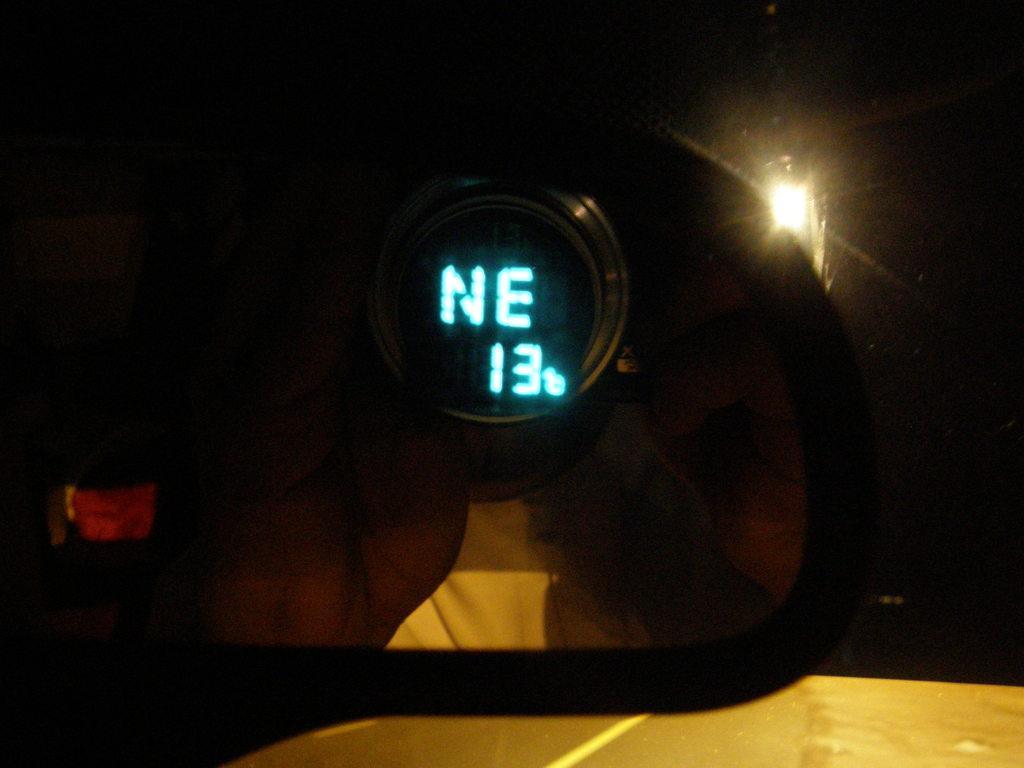Can you describe this image briefly? Here in this picture we can see a mirror of a vehicle and in that we can see some digital text present and behind that we can see a lamp post present on the ground. 